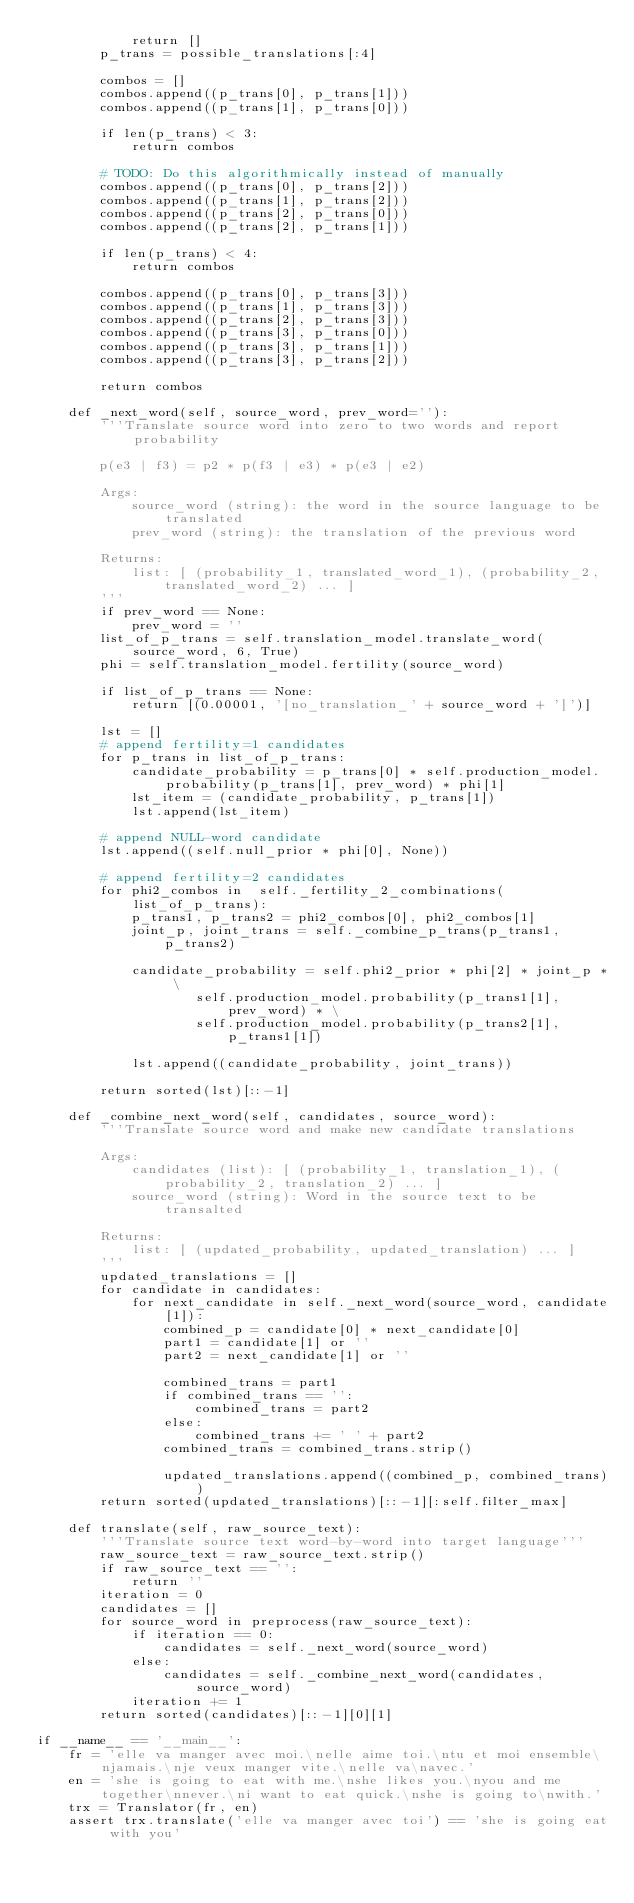<code> <loc_0><loc_0><loc_500><loc_500><_Python_>            return []
        p_trans = possible_translations[:4]

        combos = []
        combos.append((p_trans[0], p_trans[1]))
        combos.append((p_trans[1], p_trans[0]))

        if len(p_trans) < 3:
            return combos

        # TODO: Do this algorithmically instead of manually
        combos.append((p_trans[0], p_trans[2]))
        combos.append((p_trans[1], p_trans[2]))
        combos.append((p_trans[2], p_trans[0]))
        combos.append((p_trans[2], p_trans[1]))

        if len(p_trans) < 4:
            return combos

        combos.append((p_trans[0], p_trans[3]))
        combos.append((p_trans[1], p_trans[3]))
        combos.append((p_trans[2], p_trans[3]))
        combos.append((p_trans[3], p_trans[0]))
        combos.append((p_trans[3], p_trans[1]))
        combos.append((p_trans[3], p_trans[2]))

        return combos

    def _next_word(self, source_word, prev_word=''):
        '''Translate source word into zero to two words and report probability

        p(e3 | f3) = p2 * p(f3 | e3) * p(e3 | e2)

        Args:
            source_word (string): the word in the source language to be translated
            prev_word (string): the translation of the previous word

        Returns:
            list: [ (probability_1, translated_word_1), (probability_2, translated_word_2) ... ]
        '''
        if prev_word == None:
            prev_word = ''
        list_of_p_trans = self.translation_model.translate_word(source_word, 6, True)
        phi = self.translation_model.fertility(source_word)

        if list_of_p_trans == None:
            return [(0.00001, '[no_translation_' + source_word + ']')]

        lst = []
        # append fertility=1 candidates
        for p_trans in list_of_p_trans:
            candidate_probability = p_trans[0] * self.production_model.probability(p_trans[1], prev_word) * phi[1]
            lst_item = (candidate_probability, p_trans[1])
            lst.append(lst_item)

        # append NULL-word candidate
        lst.append((self.null_prior * phi[0], None))

        # append fertility=2 candidates
        for phi2_combos in  self._fertility_2_combinations(list_of_p_trans):
            p_trans1, p_trans2 = phi2_combos[0], phi2_combos[1]
            joint_p, joint_trans = self._combine_p_trans(p_trans1, p_trans2)

            candidate_probability = self.phi2_prior * phi[2] * joint_p * \
                    self.production_model.probability(p_trans1[1], prev_word) * \
                    self.production_model.probability(p_trans2[1], p_trans1[1])

            lst.append((candidate_probability, joint_trans))

        return sorted(lst)[::-1]

    def _combine_next_word(self, candidates, source_word):
        '''Translate source word and make new candidate translations

        Args:
            candidates (list): [ (probability_1, translation_1), (probability_2, translation_2) ... ]
            source_word (string): Word in the source text to be transalted

        Returns:
            list: [ (updated_probability, updated_translation) ... ]
        '''
        updated_translations = []
        for candidate in candidates:
            for next_candidate in self._next_word(source_word, candidate[1]):
                combined_p = candidate[0] * next_candidate[0]
                part1 = candidate[1] or ''
                part2 = next_candidate[1] or ''

                combined_trans = part1
                if combined_trans == '':
                    combined_trans = part2
                else:
                    combined_trans += ' ' + part2
                combined_trans = combined_trans.strip()

                updated_translations.append((combined_p, combined_trans))
        return sorted(updated_translations)[::-1][:self.filter_max]

    def translate(self, raw_source_text):
        '''Translate source text word-by-word into target language'''
        raw_source_text = raw_source_text.strip()
        if raw_source_text == '':
            return ''
        iteration = 0
        candidates = []
        for source_word in preprocess(raw_source_text):
            if iteration == 0:
                candidates = self._next_word(source_word)
            else:
                candidates = self._combine_next_word(candidates, source_word)
            iteration += 1
        return sorted(candidates)[::-1][0][1]

if __name__ == '__main__':
    fr = 'elle va manger avec moi.\nelle aime toi.\ntu et moi ensemble\njamais.\nje veux manger vite.\nelle va\navec.'
    en = 'she is going to eat with me.\nshe likes you.\nyou and me together\nnever.\ni want to eat quick.\nshe is going to\nwith.'
    trx = Translator(fr, en)
    assert trx.translate('elle va manger avec toi') == 'she is going eat with you'
</code> 